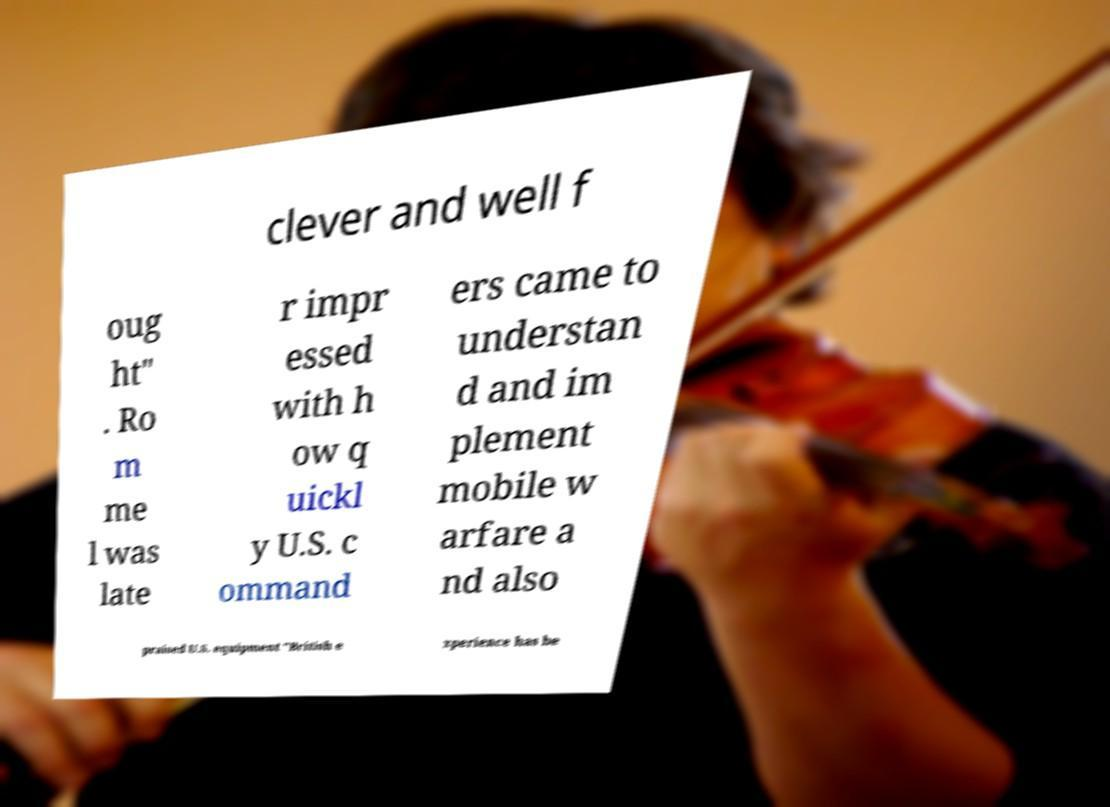For documentation purposes, I need the text within this image transcribed. Could you provide that? clever and well f oug ht" . Ro m me l was late r impr essed with h ow q uickl y U.S. c ommand ers came to understan d and im plement mobile w arfare a nd also praised U.S. equipment "British e xperience has be 